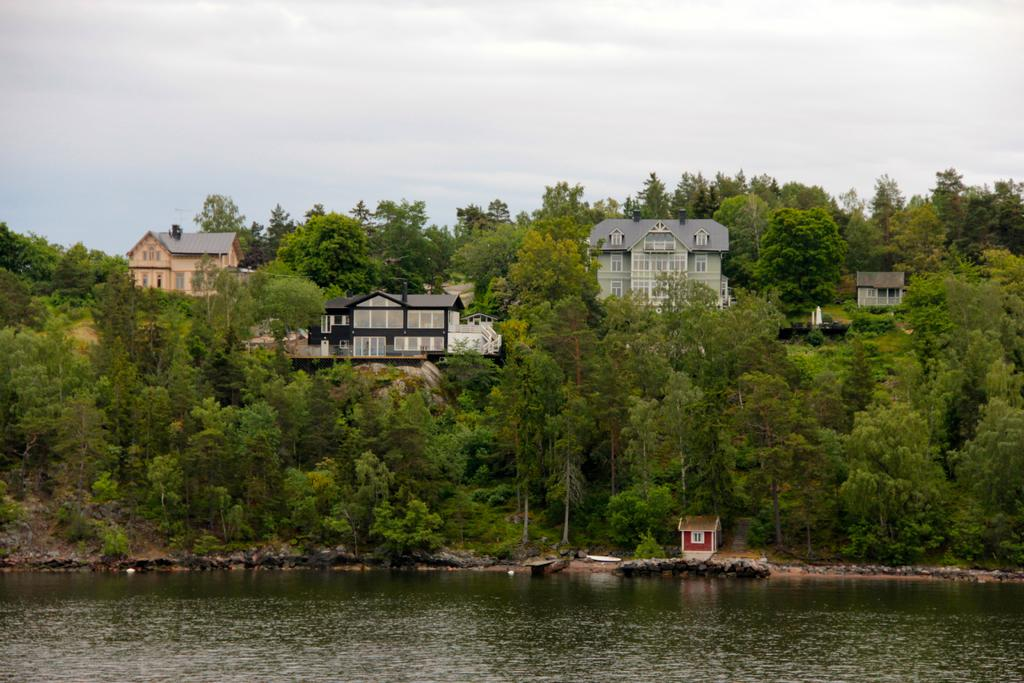What is located at the front of the image? There is a lake in the front of the image. What can be seen in the background of the image? There are buildings on a hill in the background, and trees are present on the hill. What is visible above the hill in the image? The sky is visible above the hill, and clouds are present in the sky. Where is the toothbrush located in the image? There is no toothbrush present in the image. What type of table can be seen in the image? There is no table present in the image. 